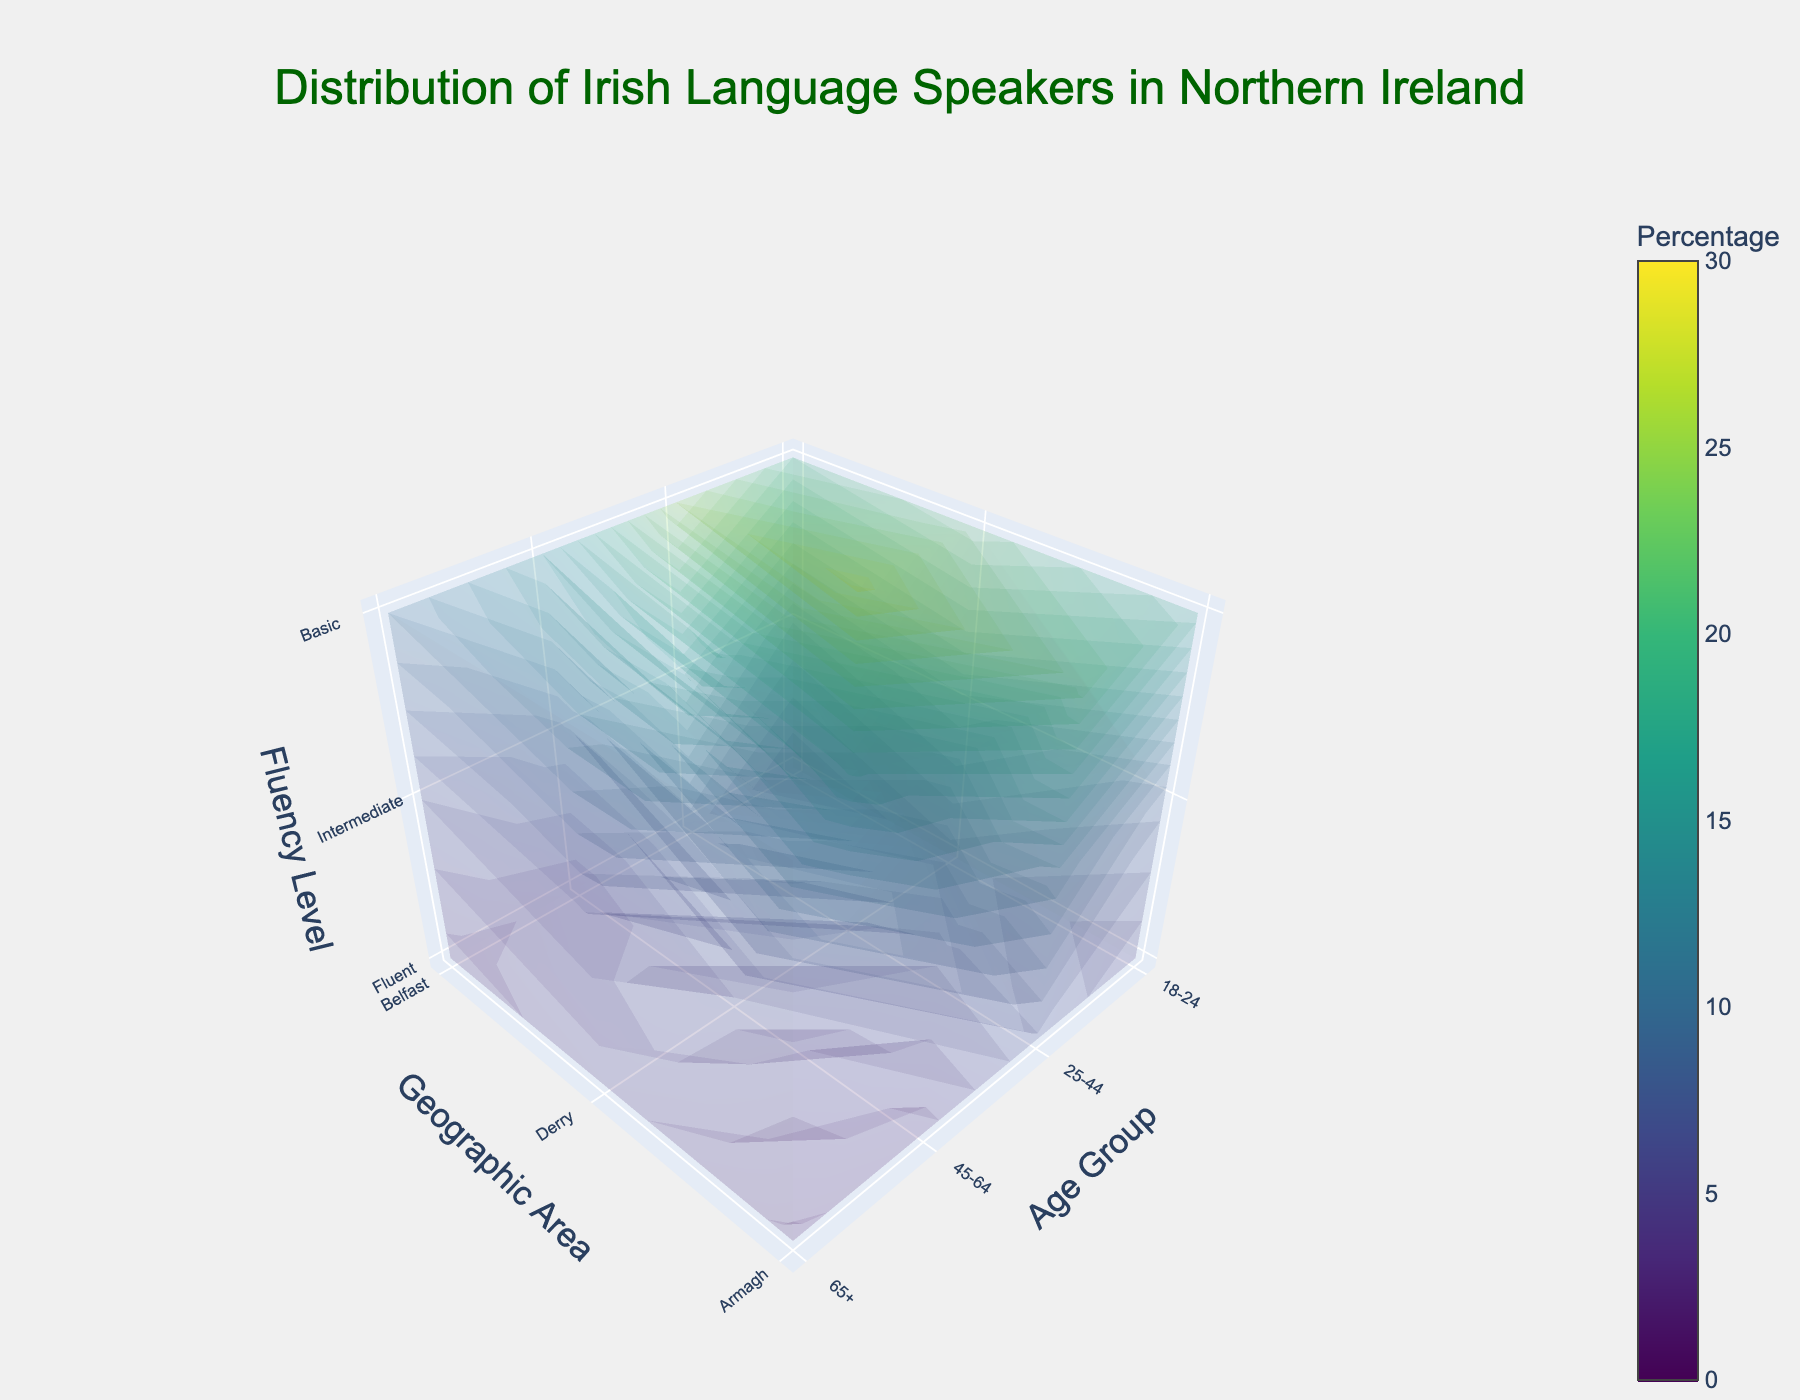What is the title of the plot? The title is usually positioned at the top of the figure, prominently displayed to summarize the main focus of the visualization.
Answer: Distribution of Irish Language Speakers in Northern Ireland Which age group in Derry has the highest percentage of fluent Irish language speakers? To determine this, we look for the tallest bar in the Derry section of the plot that corresponds to the 'Fluent' fluency level.
Answer: 25-44 Compare the percentage of intermediate Irish speakers between Armagh and Belfast in the 25-44 age group. Which is higher? Check the intermediate fluency level for the 25-44 age group in both Armagh and Belfast. The values are compared to see which is greater.
Answer: Belfast Which geographic area has the lowest percentage of basic Irish language speakers in the 65+ age group? Look at the 65+ age group for all geographic areas and compare the percentages of basic speakers; the smallest value reveals the area.
Answer: Armagh Calculate the average percentage of fluent Irish speakers across all age groups in Belfast. Sum the percentages of fluent speakers in Belfast across all age groups, then divide by the number of age groups (4). Calculation: (5+8+3+2)/4 = 18/4
Answer: 4.5 How does the percentage of basic speakers in the 45-64 age group of Armagh compare to that in the same age group of Derry? Compare the heights of the bars representing basic fluency in the 45-64 age group for Armagh and Derry.
Answer: Armagh has a lower percentage What is the overall trend in fluent Irish speakers across the four age groups in Belfast? Observe the trend in the heights of the bars representing fluent speakers in all age groups within Belfast for an increasing, decreasing, or otherwise pattern.
Answer: Decreasing 